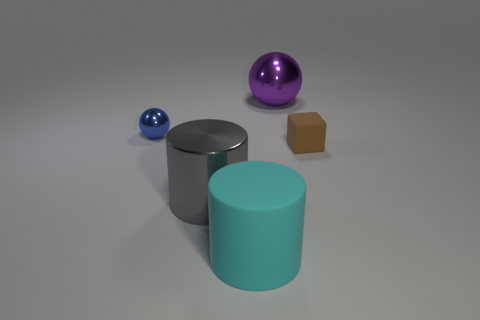Add 2 big blue cubes. How many objects exist? 7 Subtract all cubes. How many objects are left? 4 Subtract all big gray metal objects. Subtract all large rubber cylinders. How many objects are left? 3 Add 4 gray cylinders. How many gray cylinders are left? 5 Add 4 spheres. How many spheres exist? 6 Subtract 0 blue cubes. How many objects are left? 5 